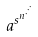Convert formula to latex. <formula><loc_0><loc_0><loc_500><loc_500>a ^ { s ^ { n ^ { \cdot ^ { \cdot ^ { \cdot } } } } }</formula> 